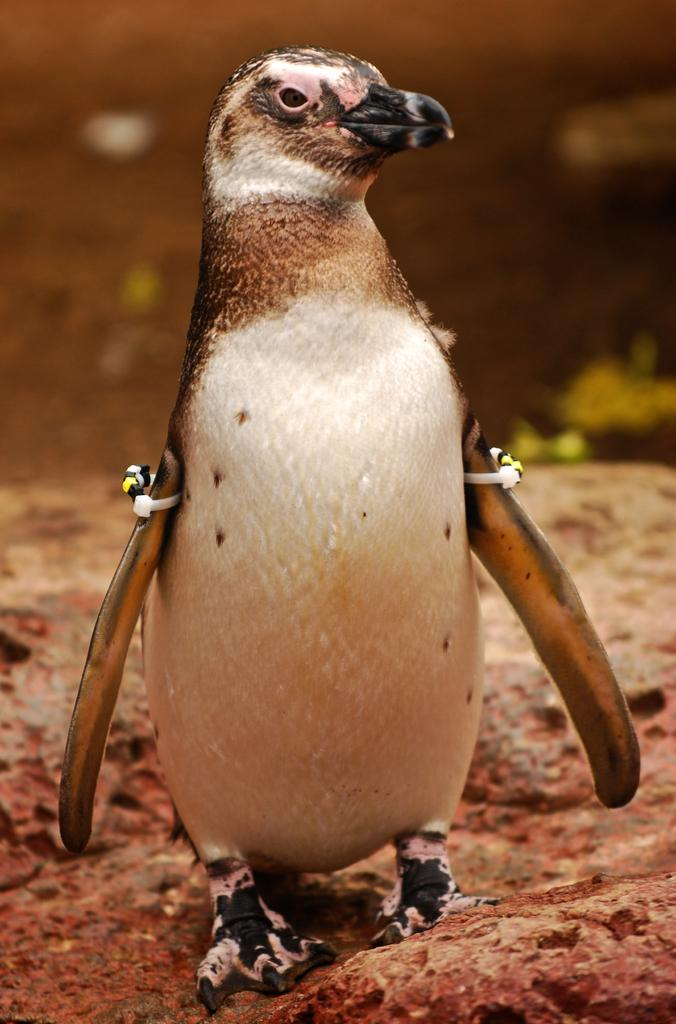What animal is present in the image? There is a penguin in the image. What is the penguin doing in the image? The penguin is standing on the ground. What type of surface is the penguin standing on? There are stones and soil on the ground. What type of veil is the penguin wearing in the image? There is no veil present in the image; the penguin is not wearing any clothing or accessories. 